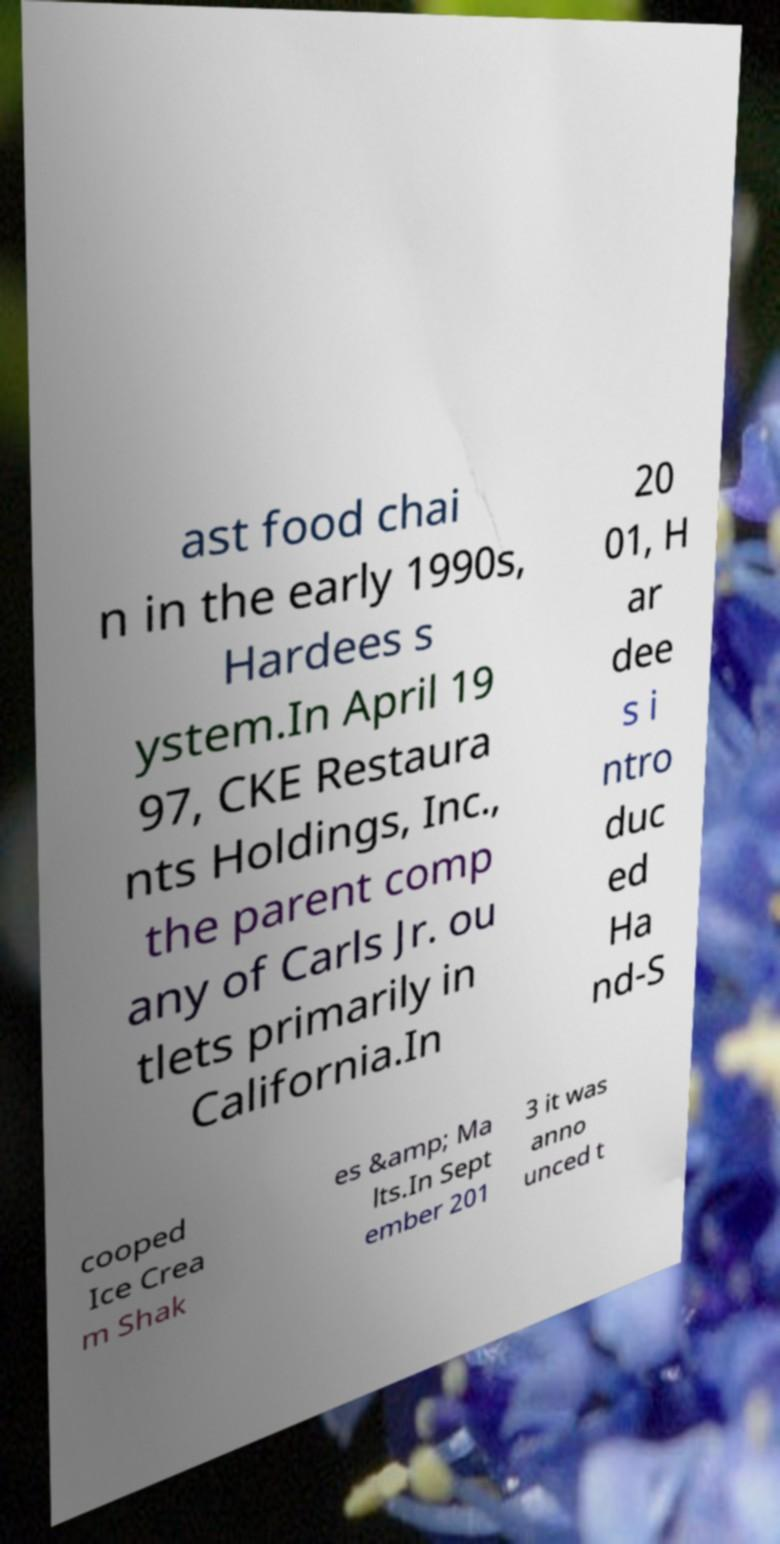There's text embedded in this image that I need extracted. Can you transcribe it verbatim? ast food chai n in the early 1990s, Hardees s ystem.In April 19 97, CKE Restaura nts Holdings, Inc., the parent comp any of Carls Jr. ou tlets primarily in California.In 20 01, H ar dee s i ntro duc ed Ha nd-S cooped Ice Crea m Shak es &amp; Ma lts.In Sept ember 201 3 it was anno unced t 